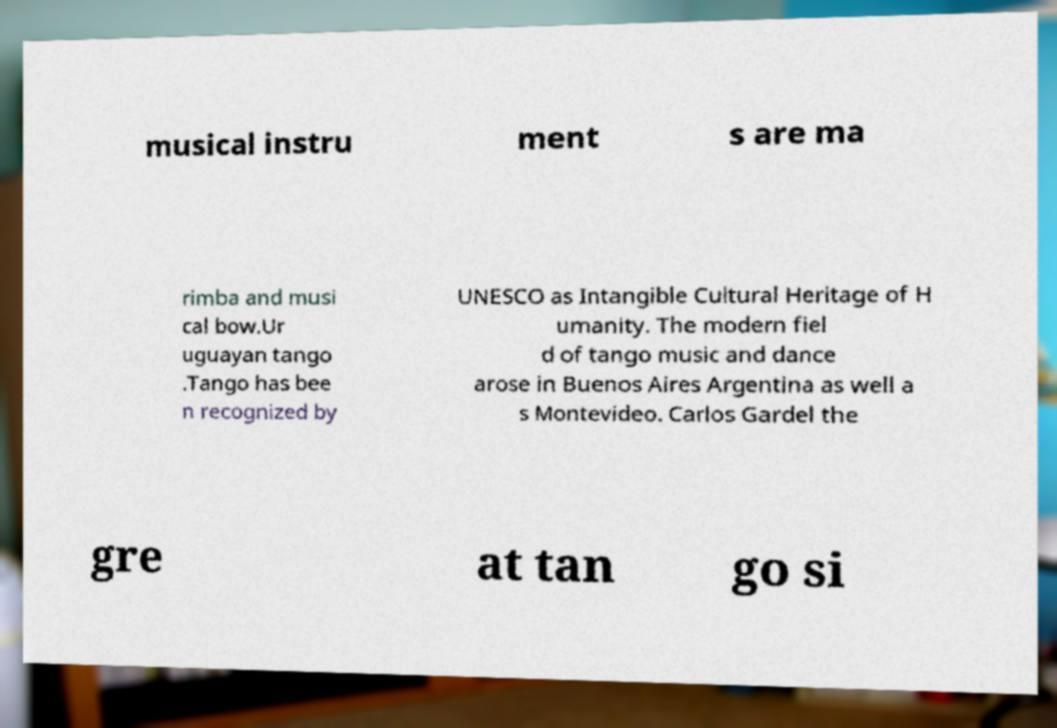Please read and relay the text visible in this image. What does it say? musical instru ment s are ma rimba and musi cal bow.Ur uguayan tango .Tango has bee n recognized by UNESCO as Intangible Cultural Heritage of H umanity. The modern fiel d of tango music and dance arose in Buenos Aires Argentina as well a s Montevideo. Carlos Gardel the gre at tan go si 